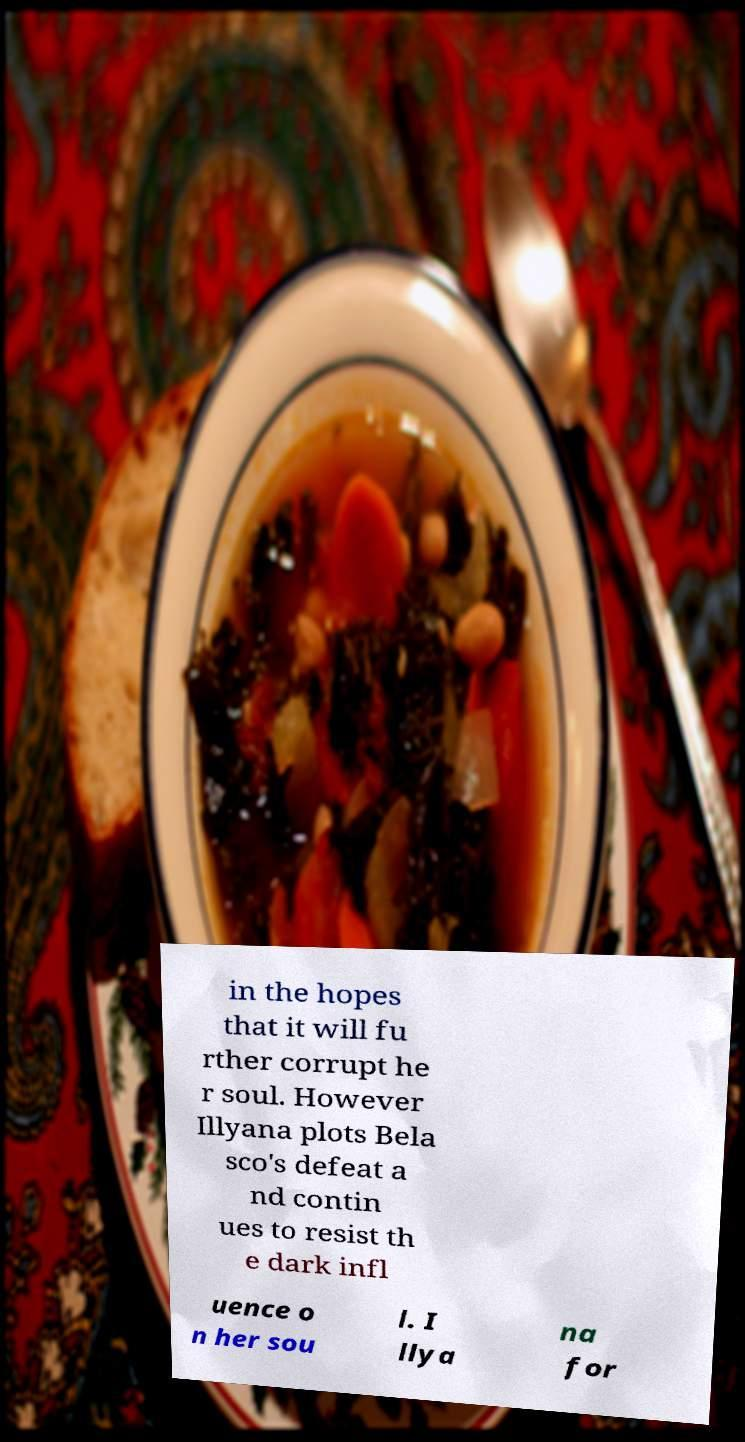Could you extract and type out the text from this image? in the hopes that it will fu rther corrupt he r soul. However Illyana plots Bela sco's defeat a nd contin ues to resist th e dark infl uence o n her sou l. I llya na for 